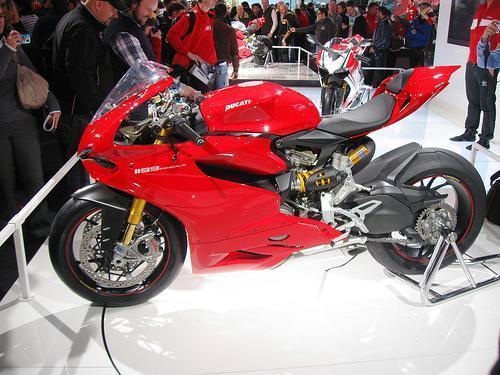How many motorcycles are there?
Give a very brief answer. 3. How many tires are visible?
Give a very brief answer. 4. 